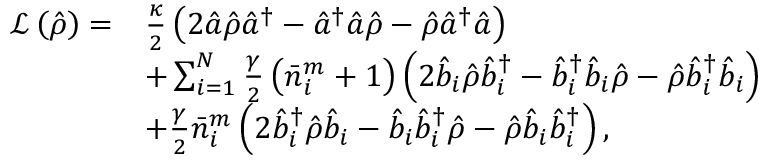Convert formula to latex. <formula><loc_0><loc_0><loc_500><loc_500>\begin{array} { r l } { \mathcal { L } \left ( \hat { \rho } \right ) = } & { \frac { \kappa } { 2 } \left ( 2 \hat { a } \hat { \rho } \hat { a } ^ { \dagger } - \hat { a } ^ { \dagger } \hat { a } \hat { \rho } - \hat { \rho } \hat { a } ^ { \dagger } \hat { a } \right ) } \\ & { + \sum _ { i = 1 } ^ { N } \frac { \gamma } { 2 } \left ( \bar { n } _ { i } ^ { m } + 1 \right ) \left ( 2 \hat { b } _ { i } \hat { \rho } \hat { b } _ { i } ^ { \dagger } - \hat { b } _ { i } ^ { \dagger } \hat { b } _ { i } \hat { \rho } - \hat { \rho } \hat { b } _ { i } ^ { \dagger } \hat { b } _ { i } \right ) } \\ & { + \frac { \gamma } { 2 } \bar { n } _ { i } ^ { m } \left ( 2 \hat { b } _ { i } ^ { \dagger } \hat { \rho } \hat { b } _ { i } - \hat { b } _ { i } \hat { b } _ { i } ^ { \dagger } \hat { \rho } - \hat { \rho } \hat { b } _ { i } \hat { b } _ { i } ^ { \dagger } \right ) , } \end{array}</formula> 